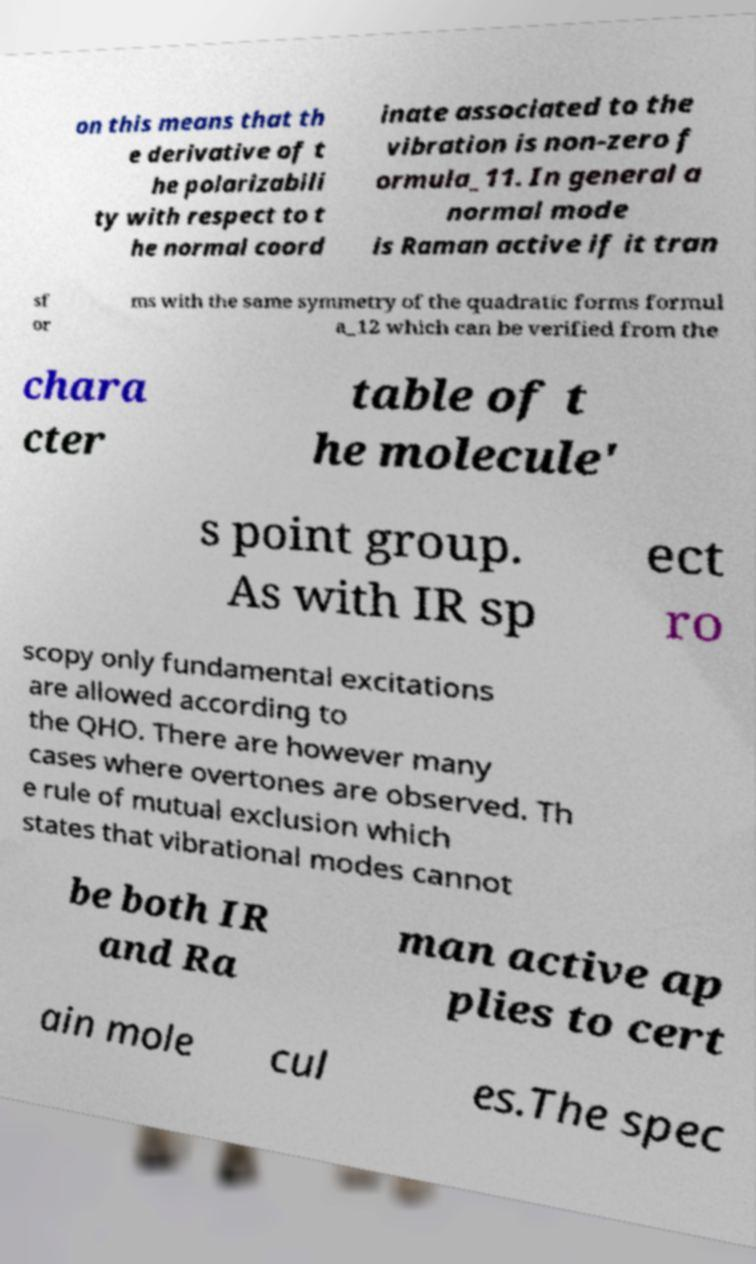For documentation purposes, I need the text within this image transcribed. Could you provide that? on this means that th e derivative of t he polarizabili ty with respect to t he normal coord inate associated to the vibration is non-zero f ormula_11. In general a normal mode is Raman active if it tran sf or ms with the same symmetry of the quadratic forms formul a_12 which can be verified from the chara cter table of t he molecule' s point group. As with IR sp ect ro scopy only fundamental excitations are allowed according to the QHO. There are however many cases where overtones are observed. Th e rule of mutual exclusion which states that vibrational modes cannot be both IR and Ra man active ap plies to cert ain mole cul es.The spec 